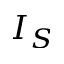<formula> <loc_0><loc_0><loc_500><loc_500>I _ { S }</formula> 